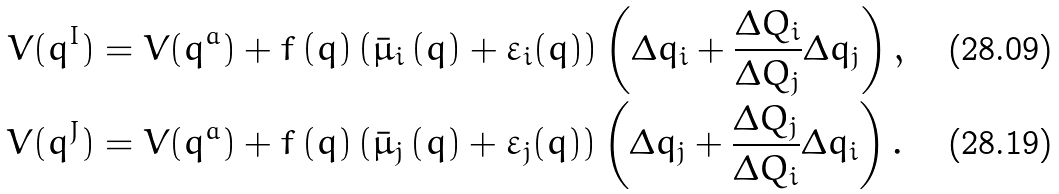Convert formula to latex. <formula><loc_0><loc_0><loc_500><loc_500>V ( q ^ { I } ) & = V ( q ^ { a } ) + f \left ( q \right ) \left ( \bar { \mu } _ { i } \left ( q \right ) + \varepsilon _ { i } ( q ) \right ) \left ( \Delta q _ { i } + \frac { \Delta Q _ { i } } { \Delta Q _ { j } } \Delta q _ { j } \right ) , \\ V ( q ^ { J } ) & = V ( q ^ { a } ) + f \left ( q \right ) \left ( \bar { \mu } _ { j } \left ( q \right ) + \varepsilon _ { j } ( q ) \right ) \left ( \Delta q _ { j } + \frac { \Delta Q _ { j } } { \Delta Q _ { i } } \Delta q _ { i } \right ) .</formula> 